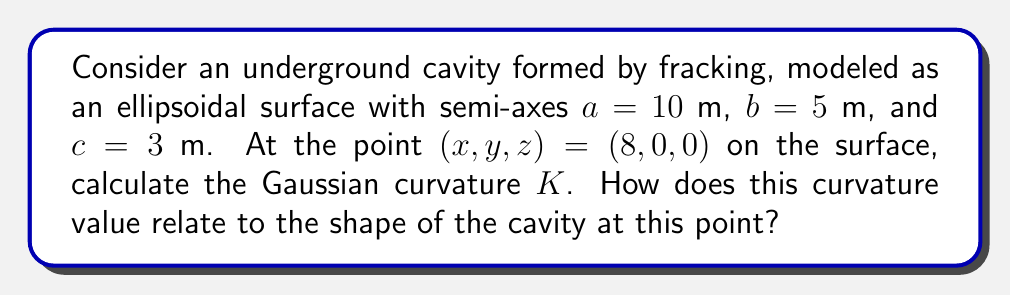What is the answer to this math problem? To solve this problem, we'll follow these steps:

1) The equation of an ellipsoid is given by:

   $$\frac{x^2}{a^2} + \frac{y^2}{b^2} + \frac{z^2}{c^2} = 1$$

2) For an ellipsoid, the Gaussian curvature $K$ at any point $(x, y, z)$ is given by:

   $$K = \frac{1}{a^2b^2c^2} \cdot \frac{1}{(\frac{x^2}{a^4} + \frac{y^2}{b^4} + \frac{z^2}{c^4})^2}$$

3) We're given $a = 10$ m, $b = 5$ m, $c = 3$ m, and the point $(8, 0, 0)$.

4) Substituting these values into the formula:

   $$K = \frac{1}{(10^2)(5^2)(3^2)} \cdot \frac{1}{(\frac{8^2}{10^4} + \frac{0^2}{5^4} + \frac{0^2}{3^4})^2}$$

5) Simplifying:

   $$K = \frac{1}{22500} \cdot \frac{1}{(\frac{64}{10000})^2} = \frac{1}{22500} \cdot \frac{10000^2}{64^2}$$

6) Calculating:

   $$K = \frac{10000}{22500 \cdot 64} = \frac{5000}{722500} \approx 0.00692 \text{ m}^{-2}$$

7) Interpretation: The positive Gaussian curvature indicates that the surface is elliptic at this point, meaning it's curved in the same direction in all orientations (like a dome). The relatively small value suggests a gentle curvature, which is consistent with being near the end of the long axis of the ellipsoid.
Answer: $K \approx 0.00692 \text{ m}^{-2}$; elliptic point with gentle curvature 